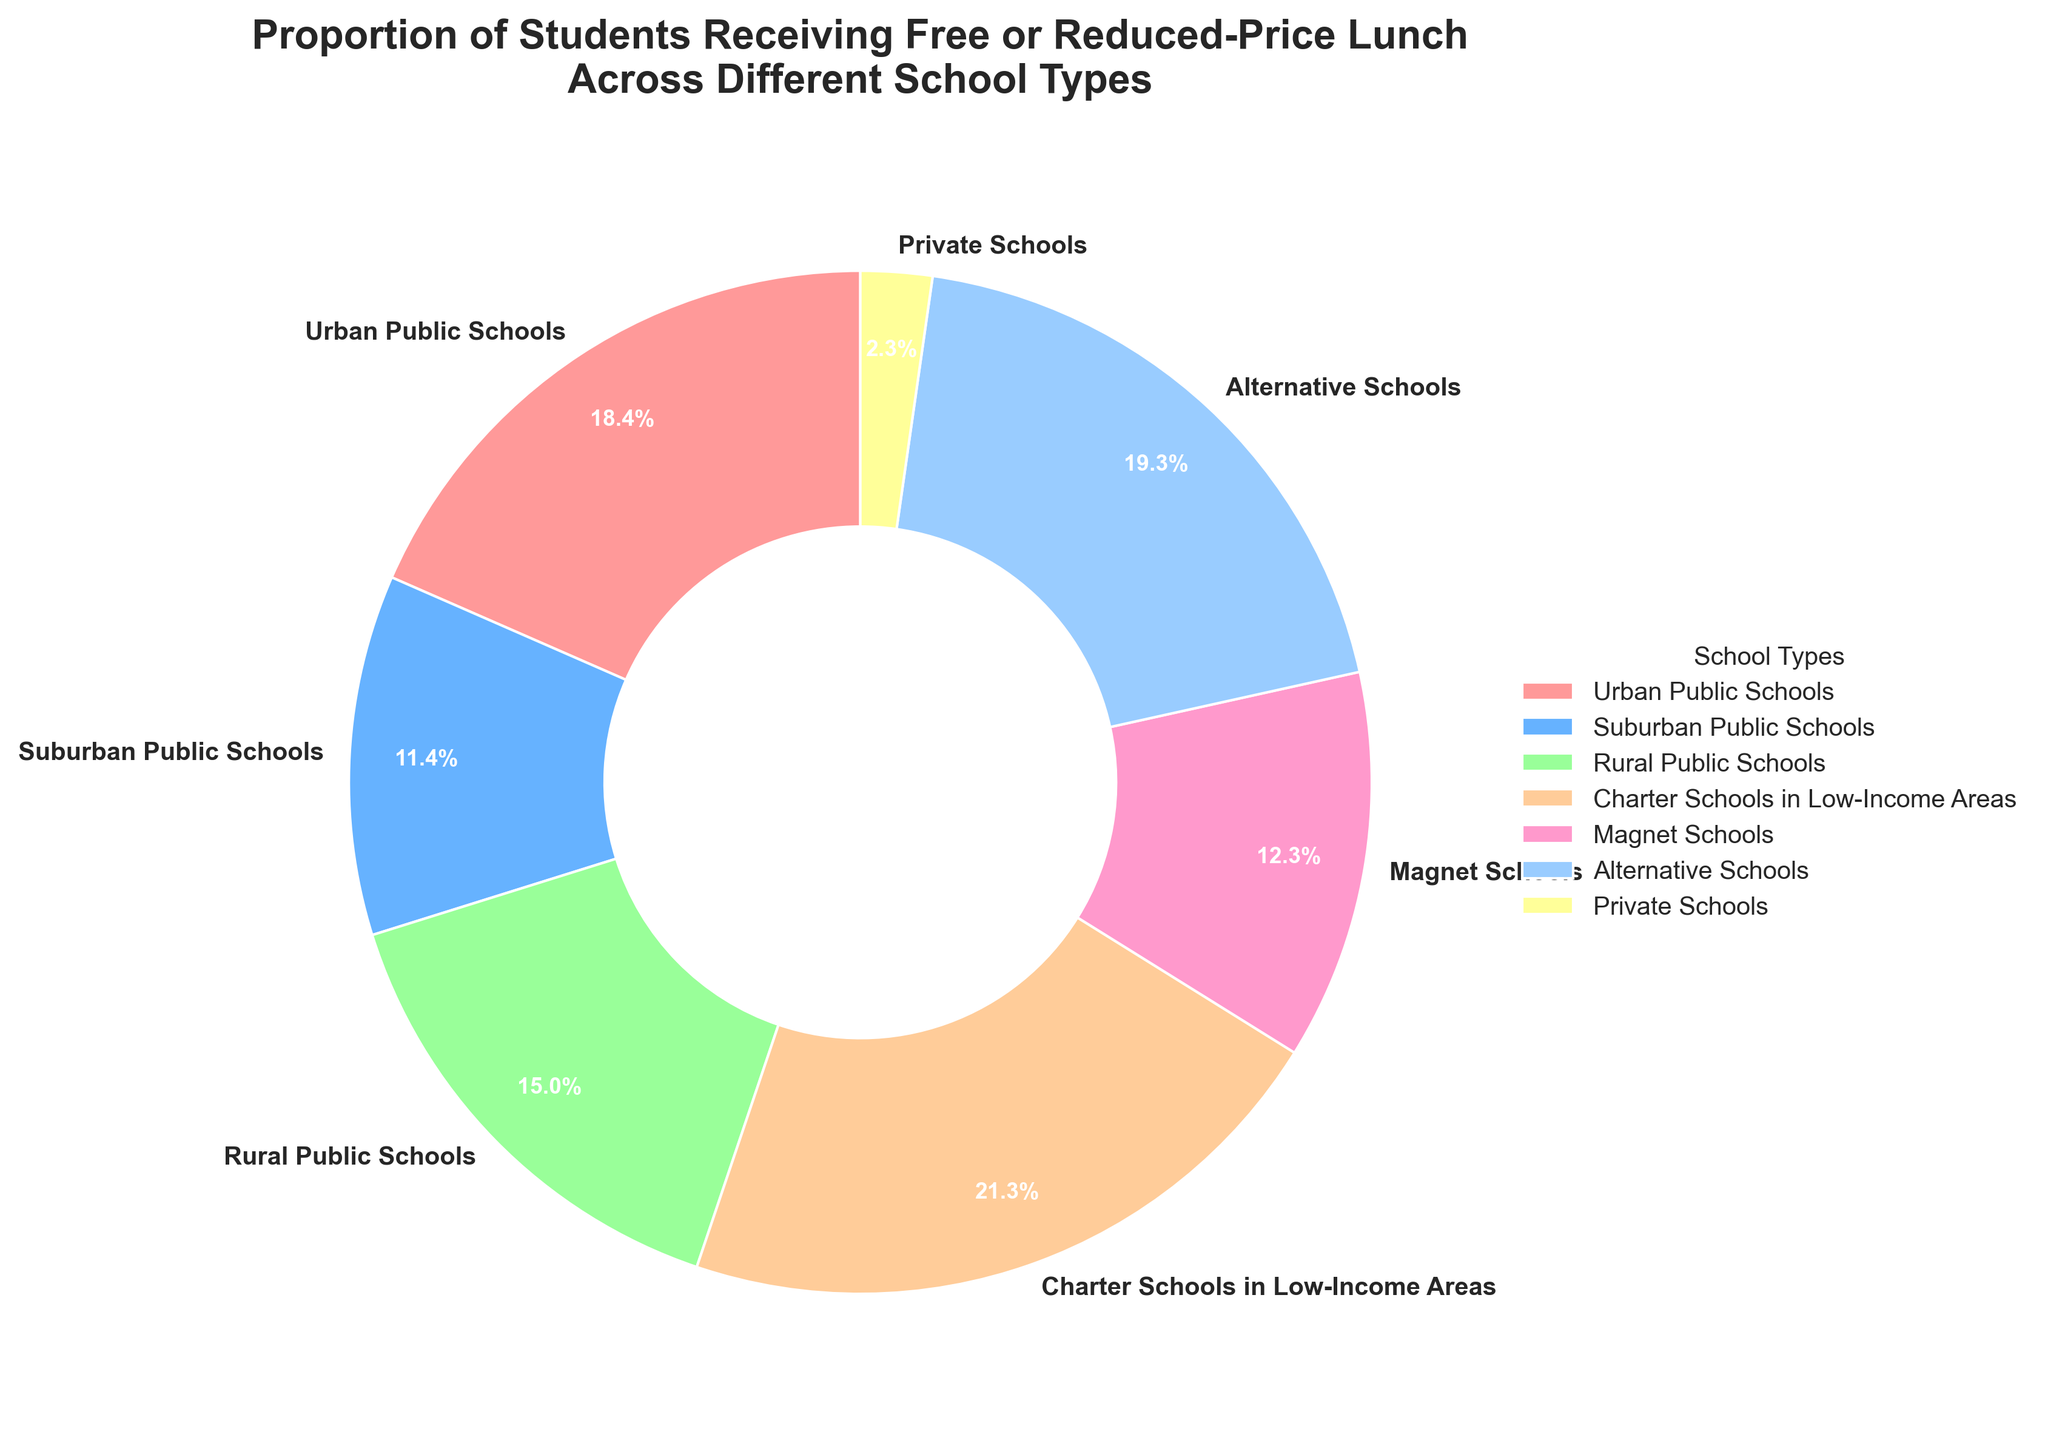What is the percentage of students receiving free or reduced-price lunch in Charter Schools in Low-Income Areas? Charter Schools in Low-Income Areas have a wedge in the pie chart labeled with the percentage of 79.2%.
Answer: 79.2% What is the difference in the percentage of students receiving free or reduced-price lunch between Urban Public Schools and Suburban Public Schools? The wedge for Urban Public Schools shows 68.5%, and for Suburban Public Schools, it shows 42.3%. Subtract the latter from the former: 68.5% - 42.3% = 26.2%.
Answer: 26.2% Which school type has the lowest percentage of students receiving free or reduced-price lunch? The wedge for Private Schools displays the lowest percentage, 8.4%.
Answer: Private Schools Compare the percentage of students receiving free or reduced-price lunch in Alternative Schools and Rural Public Schools. Which type has a higher percentage? The wedge for Alternative Schools shows 71.6%, and for Rural Public Schools, it shows 55.7%. Alternative Schools have a higher percentage.
Answer: Alternative Schools What is the median percentage of students receiving free or reduced-price lunch across all school types shown? Arrange the percentages in ascending order: 8.4%, 42.3%, 45.8%, 55.7%, 68.5%, 71.6%, 79.2%. The median is the middle value of the sorted list, which is 55.7%.
Answer: 55.7% Which school type has a percentage closest to 50% for students receiving free or reduced-price lunch? The wedges for Suburban Public Schools, Magnet Schools, and Rural Public Schools show percentages near 50%, which are 42.3%, 45.8%, and 55.7%. Magnet Schools at 45.8% is the closest to 50%.
Answer: Magnet Schools By how much does the percentage of students receiving free or reduced-price lunch in Urban Public Schools exceed that in Private Schools? The wedge for Urban Public Schools shows 68.5%, and for Private Schools, it shows 8.4%. Subtract the latter from the former: 68.5% - 8.4% = 60.1%.
Answer: 60.1% What is the combined percentage of students receiving free or reduced-price lunch in Urban Public Schools and Charter Schools in Low-Income Areas? Sum the percentages shown in the wedges for Urban Public Schools and Charter Schools in Low-Income Areas: 68.5% + 79.2% = 147.7%.
Answer: 147.7% 